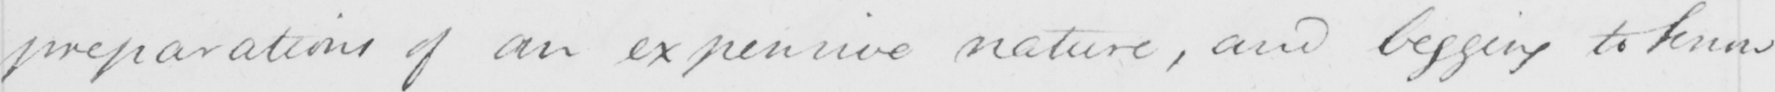Can you tell me what this handwritten text says? preparations of an expensive nature , and begging to know 